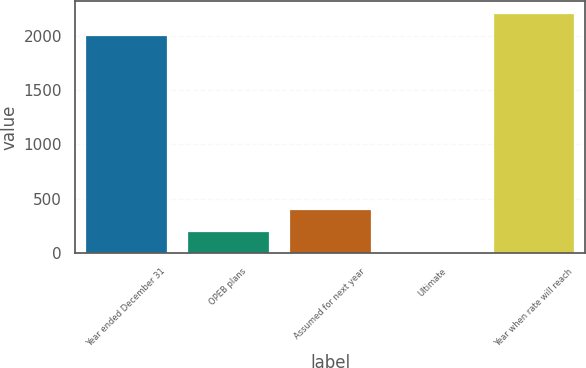<chart> <loc_0><loc_0><loc_500><loc_500><bar_chart><fcel>Year ended December 31<fcel>OPEB plans<fcel>Assumed for next year<fcel>Ultimate<fcel>Year when rate will reach<nl><fcel>2007<fcel>205.9<fcel>406.8<fcel>5<fcel>2207.9<nl></chart> 